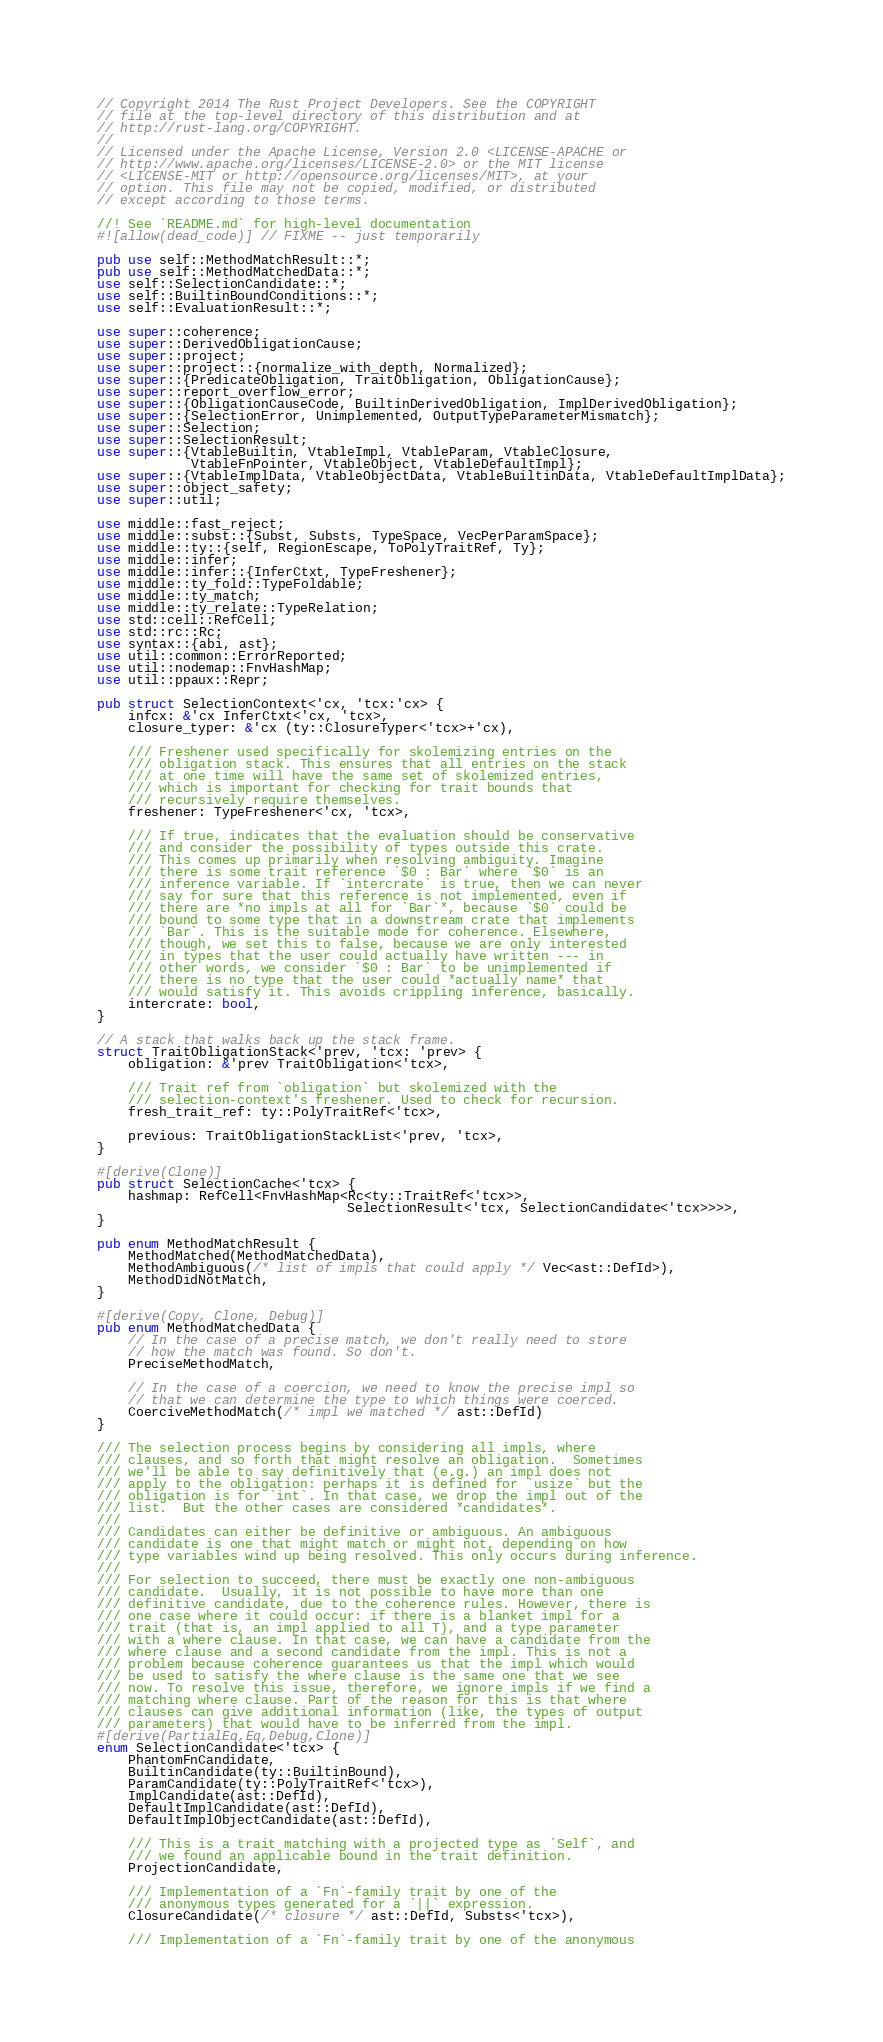<code> <loc_0><loc_0><loc_500><loc_500><_Rust_>// Copyright 2014 The Rust Project Developers. See the COPYRIGHT
// file at the top-level directory of this distribution and at
// http://rust-lang.org/COPYRIGHT.
//
// Licensed under the Apache License, Version 2.0 <LICENSE-APACHE or
// http://www.apache.org/licenses/LICENSE-2.0> or the MIT license
// <LICENSE-MIT or http://opensource.org/licenses/MIT>, at your
// option. This file may not be copied, modified, or distributed
// except according to those terms.

//! See `README.md` for high-level documentation
#![allow(dead_code)] // FIXME -- just temporarily

pub use self::MethodMatchResult::*;
pub use self::MethodMatchedData::*;
use self::SelectionCandidate::*;
use self::BuiltinBoundConditions::*;
use self::EvaluationResult::*;

use super::coherence;
use super::DerivedObligationCause;
use super::project;
use super::project::{normalize_with_depth, Normalized};
use super::{PredicateObligation, TraitObligation, ObligationCause};
use super::report_overflow_error;
use super::{ObligationCauseCode, BuiltinDerivedObligation, ImplDerivedObligation};
use super::{SelectionError, Unimplemented, OutputTypeParameterMismatch};
use super::Selection;
use super::SelectionResult;
use super::{VtableBuiltin, VtableImpl, VtableParam, VtableClosure,
            VtableFnPointer, VtableObject, VtableDefaultImpl};
use super::{VtableImplData, VtableObjectData, VtableBuiltinData, VtableDefaultImplData};
use super::object_safety;
use super::util;

use middle::fast_reject;
use middle::subst::{Subst, Substs, TypeSpace, VecPerParamSpace};
use middle::ty::{self, RegionEscape, ToPolyTraitRef, Ty};
use middle::infer;
use middle::infer::{InferCtxt, TypeFreshener};
use middle::ty_fold::TypeFoldable;
use middle::ty_match;
use middle::ty_relate::TypeRelation;
use std::cell::RefCell;
use std::rc::Rc;
use syntax::{abi, ast};
use util::common::ErrorReported;
use util::nodemap::FnvHashMap;
use util::ppaux::Repr;

pub struct SelectionContext<'cx, 'tcx:'cx> {
    infcx: &'cx InferCtxt<'cx, 'tcx>,
    closure_typer: &'cx (ty::ClosureTyper<'tcx>+'cx),

    /// Freshener used specifically for skolemizing entries on the
    /// obligation stack. This ensures that all entries on the stack
    /// at one time will have the same set of skolemized entries,
    /// which is important for checking for trait bounds that
    /// recursively require themselves.
    freshener: TypeFreshener<'cx, 'tcx>,

    /// If true, indicates that the evaluation should be conservative
    /// and consider the possibility of types outside this crate.
    /// This comes up primarily when resolving ambiguity. Imagine
    /// there is some trait reference `$0 : Bar` where `$0` is an
    /// inference variable. If `intercrate` is true, then we can never
    /// say for sure that this reference is not implemented, even if
    /// there are *no impls at all for `Bar`*, because `$0` could be
    /// bound to some type that in a downstream crate that implements
    /// `Bar`. This is the suitable mode for coherence. Elsewhere,
    /// though, we set this to false, because we are only interested
    /// in types that the user could actually have written --- in
    /// other words, we consider `$0 : Bar` to be unimplemented if
    /// there is no type that the user could *actually name* that
    /// would satisfy it. This avoids crippling inference, basically.
    intercrate: bool,
}

// A stack that walks back up the stack frame.
struct TraitObligationStack<'prev, 'tcx: 'prev> {
    obligation: &'prev TraitObligation<'tcx>,

    /// Trait ref from `obligation` but skolemized with the
    /// selection-context's freshener. Used to check for recursion.
    fresh_trait_ref: ty::PolyTraitRef<'tcx>,

    previous: TraitObligationStackList<'prev, 'tcx>,
}

#[derive(Clone)]
pub struct SelectionCache<'tcx> {
    hashmap: RefCell<FnvHashMap<Rc<ty::TraitRef<'tcx>>,
                                SelectionResult<'tcx, SelectionCandidate<'tcx>>>>,
}

pub enum MethodMatchResult {
    MethodMatched(MethodMatchedData),
    MethodAmbiguous(/* list of impls that could apply */ Vec<ast::DefId>),
    MethodDidNotMatch,
}

#[derive(Copy, Clone, Debug)]
pub enum MethodMatchedData {
    // In the case of a precise match, we don't really need to store
    // how the match was found. So don't.
    PreciseMethodMatch,

    // In the case of a coercion, we need to know the precise impl so
    // that we can determine the type to which things were coerced.
    CoerciveMethodMatch(/* impl we matched */ ast::DefId)
}

/// The selection process begins by considering all impls, where
/// clauses, and so forth that might resolve an obligation.  Sometimes
/// we'll be able to say definitively that (e.g.) an impl does not
/// apply to the obligation: perhaps it is defined for `usize` but the
/// obligation is for `int`. In that case, we drop the impl out of the
/// list.  But the other cases are considered *candidates*.
///
/// Candidates can either be definitive or ambiguous. An ambiguous
/// candidate is one that might match or might not, depending on how
/// type variables wind up being resolved. This only occurs during inference.
///
/// For selection to succeed, there must be exactly one non-ambiguous
/// candidate.  Usually, it is not possible to have more than one
/// definitive candidate, due to the coherence rules. However, there is
/// one case where it could occur: if there is a blanket impl for a
/// trait (that is, an impl applied to all T), and a type parameter
/// with a where clause. In that case, we can have a candidate from the
/// where clause and a second candidate from the impl. This is not a
/// problem because coherence guarantees us that the impl which would
/// be used to satisfy the where clause is the same one that we see
/// now. To resolve this issue, therefore, we ignore impls if we find a
/// matching where clause. Part of the reason for this is that where
/// clauses can give additional information (like, the types of output
/// parameters) that would have to be inferred from the impl.
#[derive(PartialEq,Eq,Debug,Clone)]
enum SelectionCandidate<'tcx> {
    PhantomFnCandidate,
    BuiltinCandidate(ty::BuiltinBound),
    ParamCandidate(ty::PolyTraitRef<'tcx>),
    ImplCandidate(ast::DefId),
    DefaultImplCandidate(ast::DefId),
    DefaultImplObjectCandidate(ast::DefId),

    /// This is a trait matching with a projected type as `Self`, and
    /// we found an applicable bound in the trait definition.
    ProjectionCandidate,

    /// Implementation of a `Fn`-family trait by one of the
    /// anonymous types generated for a `||` expression.
    ClosureCandidate(/* closure */ ast::DefId, Substs<'tcx>),

    /// Implementation of a `Fn`-family trait by one of the anonymous</code> 